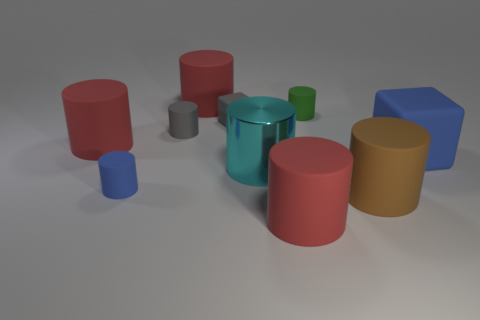What number of objects are large red metallic cylinders or tiny things?
Make the answer very short. 4. Is there a big matte cylinder of the same color as the large metallic object?
Offer a terse response. No. There is a rubber thing that is on the left side of the blue rubber cylinder; what number of rubber things are on the right side of it?
Offer a very short reply. 8. Is the number of tiny gray rubber blocks greater than the number of gray shiny cylinders?
Your answer should be compact. Yes. Are the big brown thing and the big blue block made of the same material?
Keep it short and to the point. Yes. Are there the same number of small green rubber cylinders that are in front of the brown cylinder and cyan matte cylinders?
Offer a very short reply. Yes. How many other tiny cylinders have the same material as the blue cylinder?
Ensure brevity in your answer.  2. Is the number of matte cylinders less than the number of small blocks?
Offer a very short reply. No. There is a small cylinder that is in front of the gray cylinder; is it the same color as the large cube?
Provide a short and direct response. Yes. What number of rubber things are left of the big matte object behind the small rubber cylinder that is behind the gray matte cylinder?
Your answer should be compact. 3. 